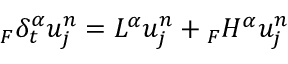Convert formula to latex. <formula><loc_0><loc_0><loc_500><loc_500>{ } _ { F } \delta _ { t } ^ { \alpha } u _ { j } ^ { n } = L ^ { \alpha } u _ { j } ^ { n } _ { F } H ^ { \alpha } u _ { j } ^ { n }</formula> 